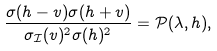Convert formula to latex. <formula><loc_0><loc_0><loc_500><loc_500>\frac { \sigma ( h - v ) \sigma ( h + v ) } { \sigma _ { \mathcal { I } } ( v ) ^ { 2 } \sigma ( h ) ^ { 2 } } = \mathcal { P } ( \lambda , h ) ,</formula> 